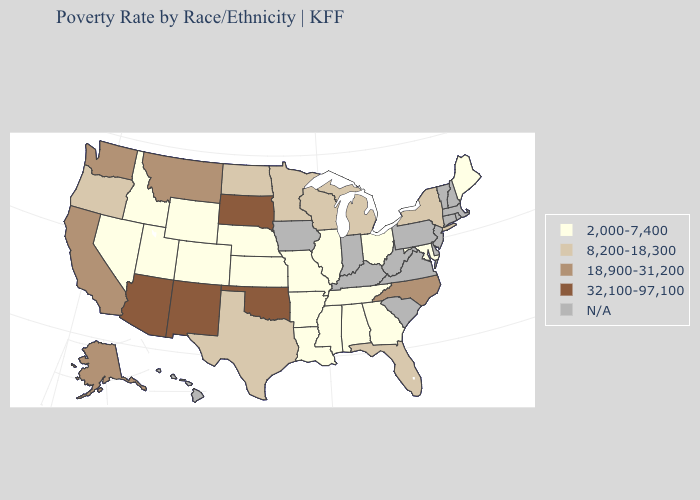Which states have the lowest value in the West?
Concise answer only. Colorado, Idaho, Nevada, Utah, Wyoming. Does Illinois have the highest value in the USA?
Keep it brief. No. Name the states that have a value in the range N/A?
Write a very short answer. Connecticut, Delaware, Hawaii, Indiana, Iowa, Kentucky, Massachusetts, New Hampshire, New Jersey, Pennsylvania, Rhode Island, South Carolina, Vermont, Virginia, West Virginia. Which states have the lowest value in the Northeast?
Quick response, please. Maine. Name the states that have a value in the range N/A?
Give a very brief answer. Connecticut, Delaware, Hawaii, Indiana, Iowa, Kentucky, Massachusetts, New Hampshire, New Jersey, Pennsylvania, Rhode Island, South Carolina, Vermont, Virginia, West Virginia. What is the value of Florida?
Concise answer only. 8,200-18,300. What is the highest value in states that border New Jersey?
Keep it brief. 8,200-18,300. Does Arizona have the highest value in the USA?
Answer briefly. Yes. Among the states that border Wisconsin , which have the highest value?
Keep it brief. Michigan, Minnesota. What is the lowest value in the USA?
Write a very short answer. 2,000-7,400. Name the states that have a value in the range 32,100-97,100?
Short answer required. Arizona, New Mexico, Oklahoma, South Dakota. Name the states that have a value in the range 32,100-97,100?
Keep it brief. Arizona, New Mexico, Oklahoma, South Dakota. What is the value of North Carolina?
Quick response, please. 18,900-31,200. What is the value of Oklahoma?
Concise answer only. 32,100-97,100. 